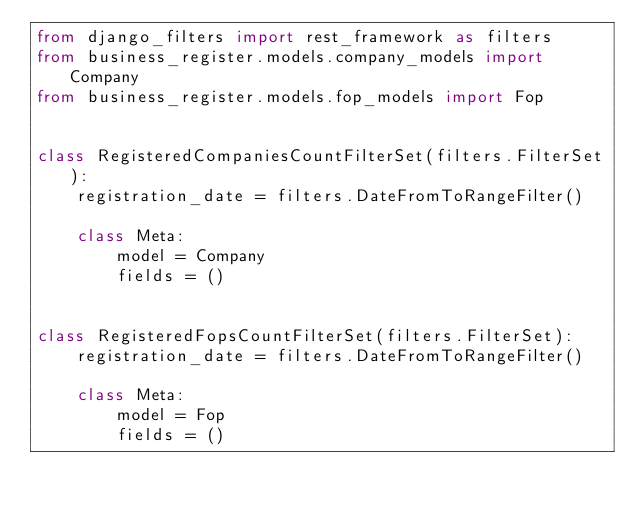Convert code to text. <code><loc_0><loc_0><loc_500><loc_500><_Python_>from django_filters import rest_framework as filters
from business_register.models.company_models import Company
from business_register.models.fop_models import Fop


class RegisteredCompaniesCountFilterSet(filters.FilterSet):
    registration_date = filters.DateFromToRangeFilter()

    class Meta:
        model = Company
        fields = ()


class RegisteredFopsCountFilterSet(filters.FilterSet):
    registration_date = filters.DateFromToRangeFilter()

    class Meta:
        model = Fop
        fields = ()
</code> 